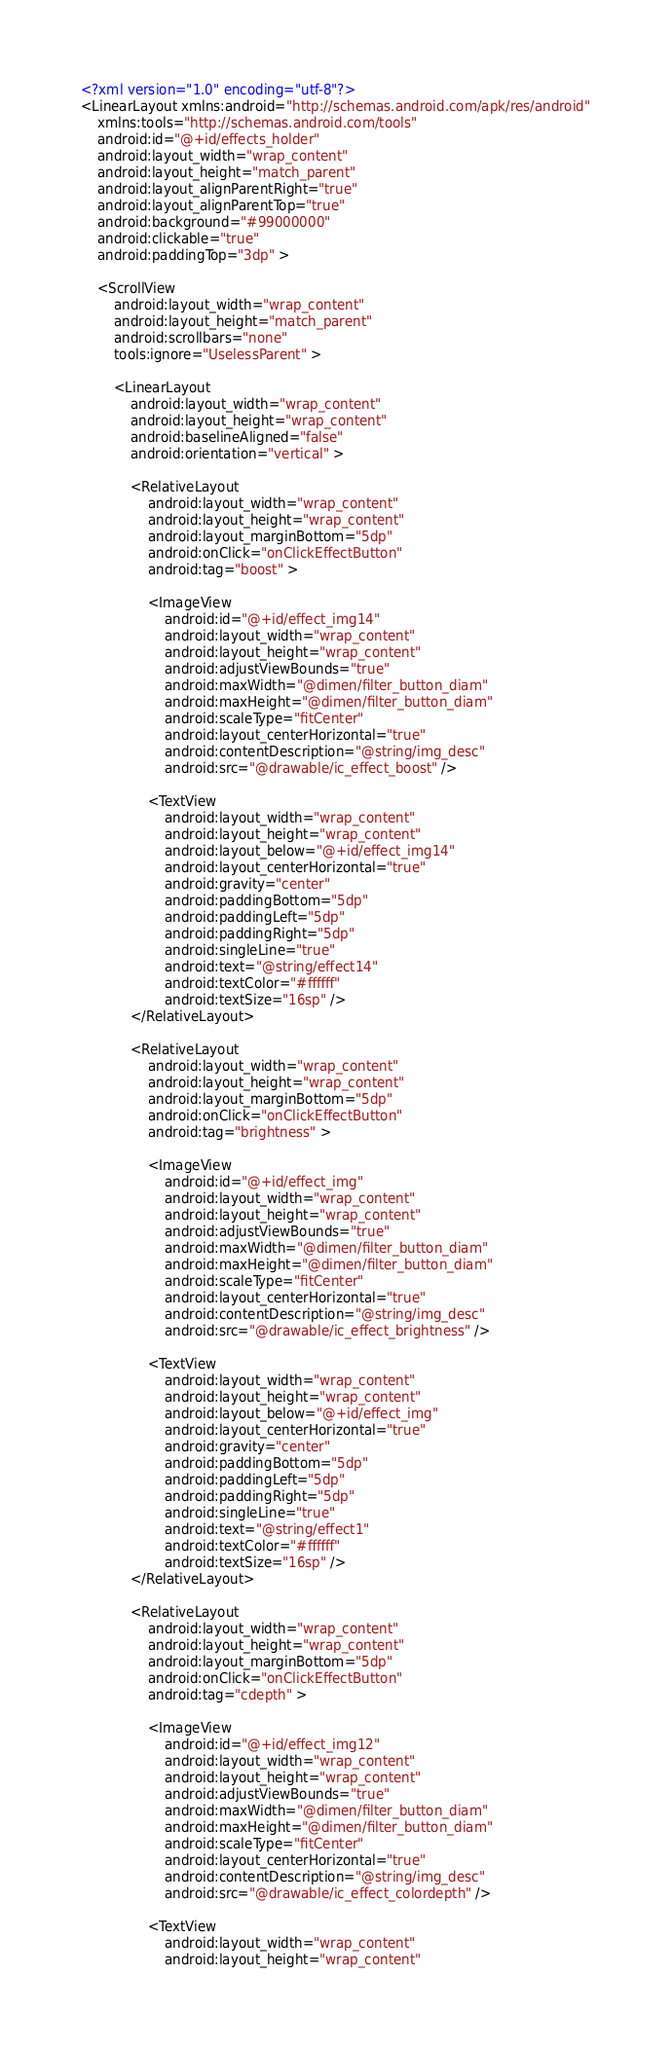Convert code to text. <code><loc_0><loc_0><loc_500><loc_500><_XML_><?xml version="1.0" encoding="utf-8"?>
<LinearLayout xmlns:android="http://schemas.android.com/apk/res/android"
    xmlns:tools="http://schemas.android.com/tools"
    android:id="@+id/effects_holder"
    android:layout_width="wrap_content"
    android:layout_height="match_parent"
    android:layout_alignParentRight="true"
    android:layout_alignParentTop="true"
    android:background="#99000000"
    android:clickable="true"
    android:paddingTop="3dp" >

    <ScrollView
        android:layout_width="wrap_content"
        android:layout_height="match_parent"
        android:scrollbars="none"
        tools:ignore="UselessParent" >

        <LinearLayout
            android:layout_width="wrap_content"
            android:layout_height="wrap_content"
            android:baselineAligned="false"
            android:orientation="vertical" >

            <RelativeLayout
                android:layout_width="wrap_content"
                android:layout_height="wrap_content"
                android:layout_marginBottom="5dp"
                android:onClick="onClickEffectButton"
                android:tag="boost" >

                <ImageView
                    android:id="@+id/effect_img14"
                    android:layout_width="wrap_content"
                    android:layout_height="wrap_content"
                    android:adjustViewBounds="true"  
            		android:maxWidth="@dimen/filter_button_diam"  
 					android:maxHeight="@dimen/filter_button_diam"  
            		android:scaleType="fitCenter"
                    android:layout_centerHorizontal="true"
                    android:contentDescription="@string/img_desc"
                    android:src="@drawable/ic_effect_boost" />

                <TextView
                    android:layout_width="wrap_content"
                    android:layout_height="wrap_content"
                    android:layout_below="@+id/effect_img14"
                    android:layout_centerHorizontal="true"
                    android:gravity="center"
                    android:paddingBottom="5dp"
                    android:paddingLeft="5dp"
                    android:paddingRight="5dp"
                    android:singleLine="true"
                    android:text="@string/effect14"
                    android:textColor="#ffffff"
                    android:textSize="16sp" />
            </RelativeLayout>

            <RelativeLayout
                android:layout_width="wrap_content"
                android:layout_height="wrap_content"
                android:layout_marginBottom="5dp"
                android:onClick="onClickEffectButton"
                android:tag="brightness" >

                <ImageView
                    android:id="@+id/effect_img"
                    android:layout_width="wrap_content"
                    android:layout_height="wrap_content"
                    android:adjustViewBounds="true"  
            		android:maxWidth="@dimen/filter_button_diam"  
 					android:maxHeight="@dimen/filter_button_diam"  
            		android:scaleType="fitCenter"
            		android:layout_centerHorizontal="true"
                    android:contentDescription="@string/img_desc"
                    android:src="@drawable/ic_effect_brightness" />

                <TextView
                    android:layout_width="wrap_content"
                    android:layout_height="wrap_content"
                    android:layout_below="@+id/effect_img"
                    android:layout_centerHorizontal="true"
                    android:gravity="center"
                    android:paddingBottom="5dp"
                    android:paddingLeft="5dp"
                    android:paddingRight="5dp"
                    android:singleLine="true"
                    android:text="@string/effect1"
                    android:textColor="#ffffff"
                    android:textSize="16sp" />
            </RelativeLayout>

            <RelativeLayout
                android:layout_width="wrap_content"
                android:layout_height="wrap_content"
                android:layout_marginBottom="5dp"
                android:onClick="onClickEffectButton"
                android:tag="cdepth" >

                <ImageView
                    android:id="@+id/effect_img12"
                    android:layout_width="wrap_content"
                    android:layout_height="wrap_content"
                    android:adjustViewBounds="true"  
            		android:maxWidth="@dimen/filter_button_diam"  
 					android:maxHeight="@dimen/filter_button_diam"  
            		android:scaleType="fitCenter"
                    android:layout_centerHorizontal="true"
                    android:contentDescription="@string/img_desc"
                    android:src="@drawable/ic_effect_colordepth" />

                <TextView
                    android:layout_width="wrap_content"
                    android:layout_height="wrap_content"</code> 